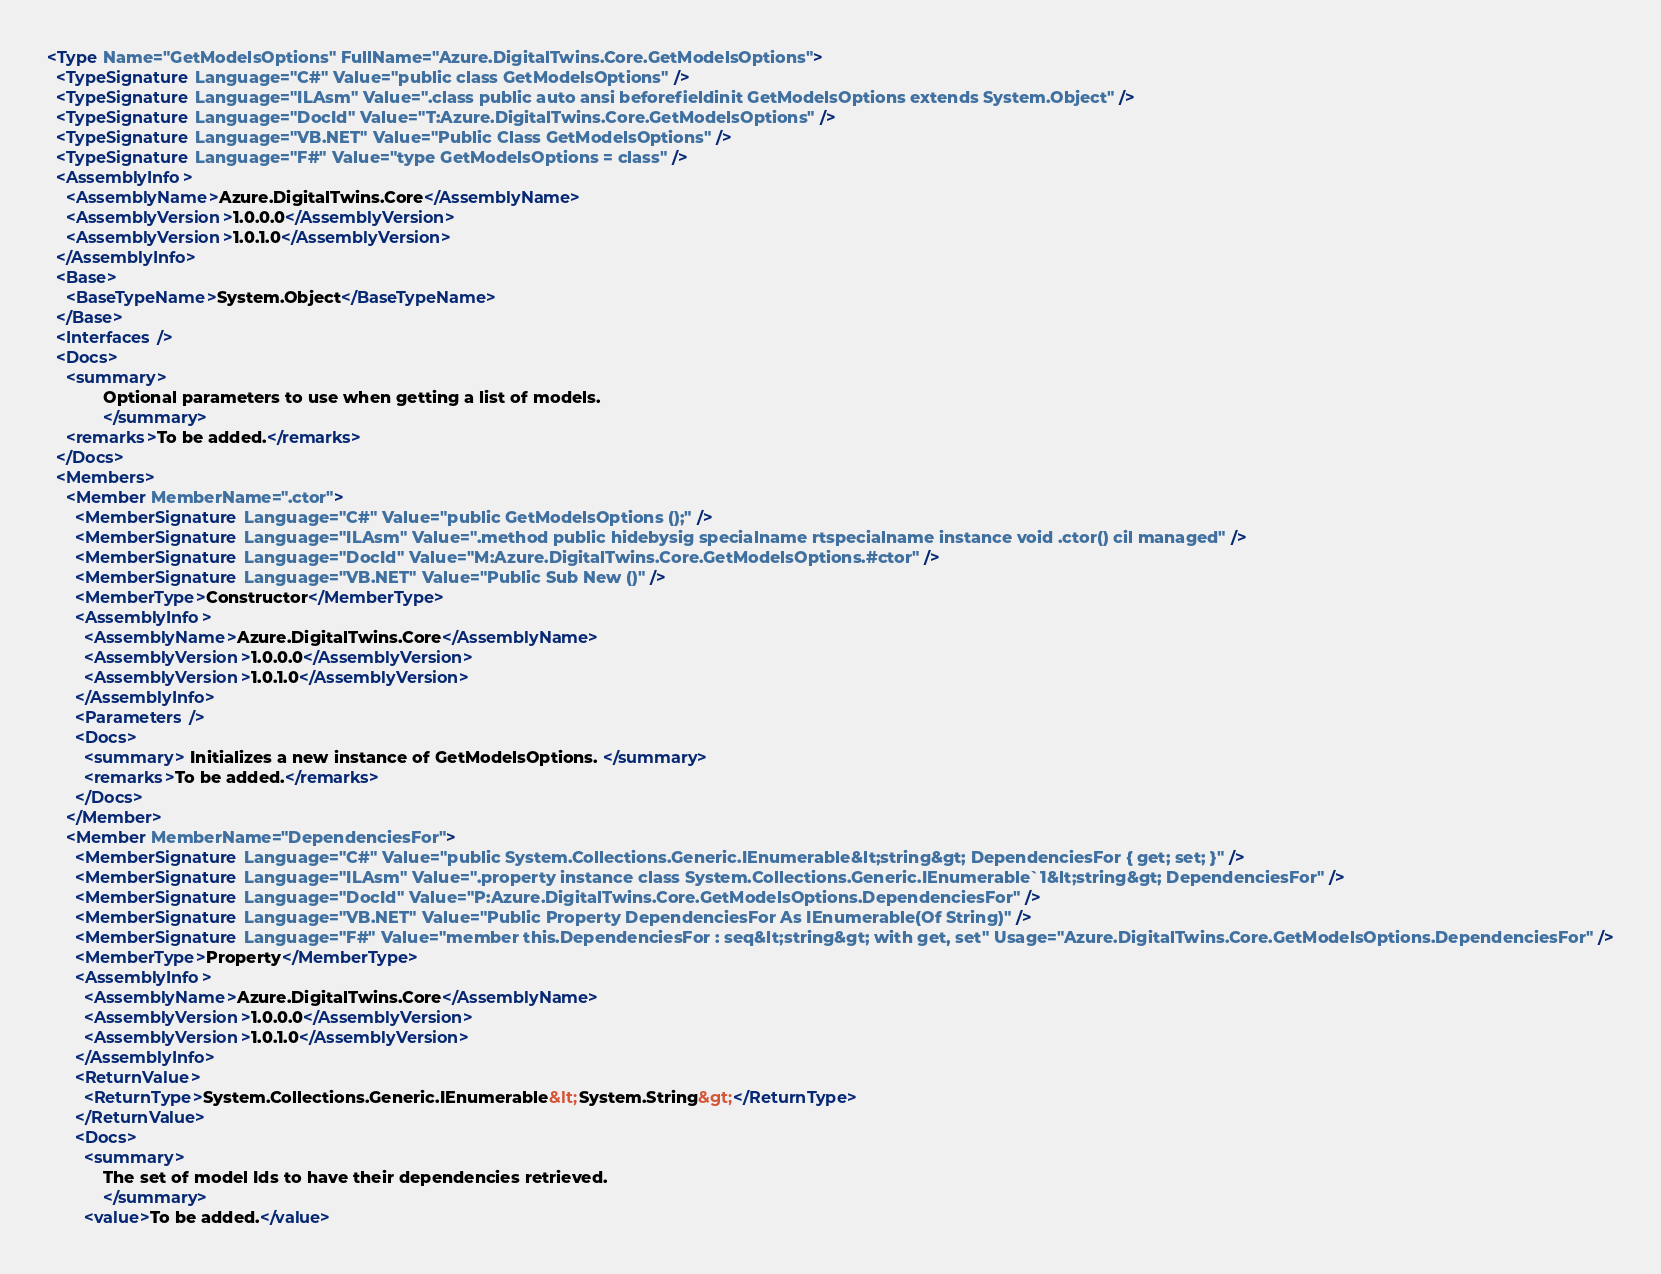Convert code to text. <code><loc_0><loc_0><loc_500><loc_500><_XML_><Type Name="GetModelsOptions" FullName="Azure.DigitalTwins.Core.GetModelsOptions">
  <TypeSignature Language="C#" Value="public class GetModelsOptions" />
  <TypeSignature Language="ILAsm" Value=".class public auto ansi beforefieldinit GetModelsOptions extends System.Object" />
  <TypeSignature Language="DocId" Value="T:Azure.DigitalTwins.Core.GetModelsOptions" />
  <TypeSignature Language="VB.NET" Value="Public Class GetModelsOptions" />
  <TypeSignature Language="F#" Value="type GetModelsOptions = class" />
  <AssemblyInfo>
    <AssemblyName>Azure.DigitalTwins.Core</AssemblyName>
    <AssemblyVersion>1.0.0.0</AssemblyVersion>
    <AssemblyVersion>1.0.1.0</AssemblyVersion>
  </AssemblyInfo>
  <Base>
    <BaseTypeName>System.Object</BaseTypeName>
  </Base>
  <Interfaces />
  <Docs>
    <summary>
            Optional parameters to use when getting a list of models.
            </summary>
    <remarks>To be added.</remarks>
  </Docs>
  <Members>
    <Member MemberName=".ctor">
      <MemberSignature Language="C#" Value="public GetModelsOptions ();" />
      <MemberSignature Language="ILAsm" Value=".method public hidebysig specialname rtspecialname instance void .ctor() cil managed" />
      <MemberSignature Language="DocId" Value="M:Azure.DigitalTwins.Core.GetModelsOptions.#ctor" />
      <MemberSignature Language="VB.NET" Value="Public Sub New ()" />
      <MemberType>Constructor</MemberType>
      <AssemblyInfo>
        <AssemblyName>Azure.DigitalTwins.Core</AssemblyName>
        <AssemblyVersion>1.0.0.0</AssemblyVersion>
        <AssemblyVersion>1.0.1.0</AssemblyVersion>
      </AssemblyInfo>
      <Parameters />
      <Docs>
        <summary> Initializes a new instance of GetModelsOptions. </summary>
        <remarks>To be added.</remarks>
      </Docs>
    </Member>
    <Member MemberName="DependenciesFor">
      <MemberSignature Language="C#" Value="public System.Collections.Generic.IEnumerable&lt;string&gt; DependenciesFor { get; set; }" />
      <MemberSignature Language="ILAsm" Value=".property instance class System.Collections.Generic.IEnumerable`1&lt;string&gt; DependenciesFor" />
      <MemberSignature Language="DocId" Value="P:Azure.DigitalTwins.Core.GetModelsOptions.DependenciesFor" />
      <MemberSignature Language="VB.NET" Value="Public Property DependenciesFor As IEnumerable(Of String)" />
      <MemberSignature Language="F#" Value="member this.DependenciesFor : seq&lt;string&gt; with get, set" Usage="Azure.DigitalTwins.Core.GetModelsOptions.DependenciesFor" />
      <MemberType>Property</MemberType>
      <AssemblyInfo>
        <AssemblyName>Azure.DigitalTwins.Core</AssemblyName>
        <AssemblyVersion>1.0.0.0</AssemblyVersion>
        <AssemblyVersion>1.0.1.0</AssemblyVersion>
      </AssemblyInfo>
      <ReturnValue>
        <ReturnType>System.Collections.Generic.IEnumerable&lt;System.String&gt;</ReturnType>
      </ReturnValue>
      <Docs>
        <summary>
            The set of model Ids to have their dependencies retrieved.
            </summary>
        <value>To be added.</value></code> 